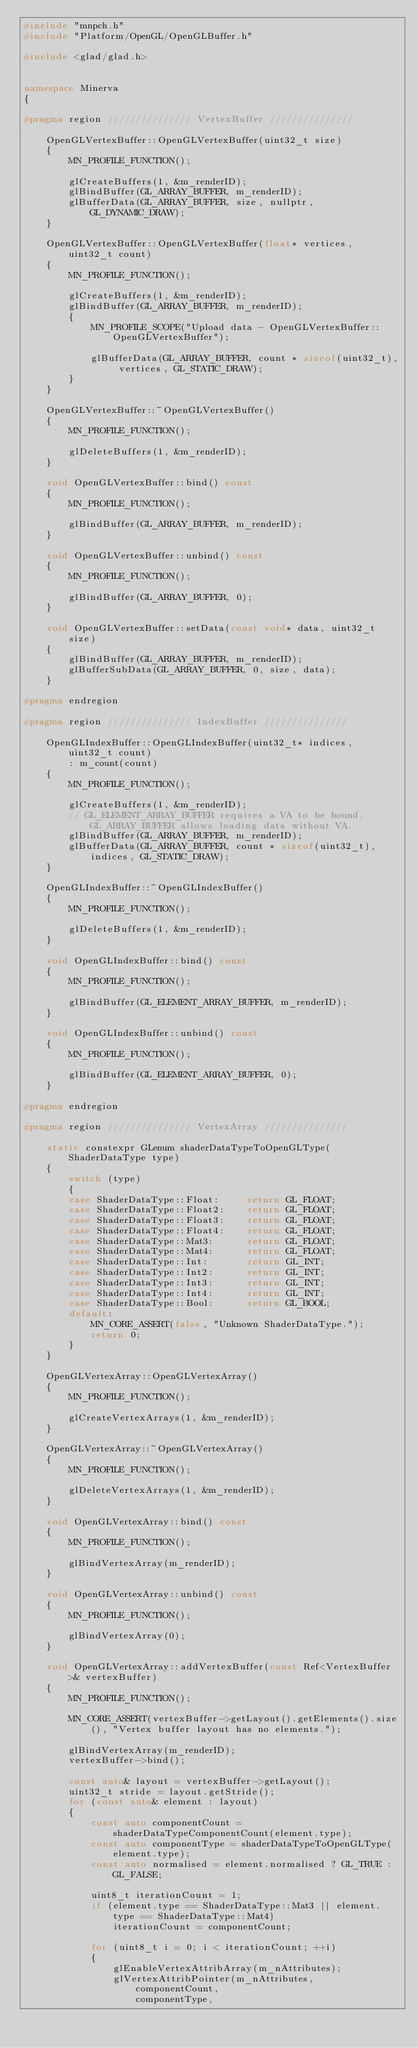Convert code to text. <code><loc_0><loc_0><loc_500><loc_500><_C++_>#include "mnpch.h"
#include "Platform/OpenGL/OpenGLBuffer.h"

#include <glad/glad.h>


namespace Minerva
{

#pragma region /////////////// VertexBuffer ///////////////

	OpenGLVertexBuffer::OpenGLVertexBuffer(uint32_t size)
	{
		MN_PROFILE_FUNCTION();

		glCreateBuffers(1, &m_renderID);
		glBindBuffer(GL_ARRAY_BUFFER, m_renderID);
		glBufferData(GL_ARRAY_BUFFER, size, nullptr, GL_DYNAMIC_DRAW);
	}

	OpenGLVertexBuffer::OpenGLVertexBuffer(float* vertices, uint32_t count)
	{
		MN_PROFILE_FUNCTION();

		glCreateBuffers(1, &m_renderID);
		glBindBuffer(GL_ARRAY_BUFFER, m_renderID);
		{
			MN_PROFILE_SCOPE("Upload data - OpenGLVertexBuffer::OpenGLVertexBuffer");

			glBufferData(GL_ARRAY_BUFFER, count * sizeof(uint32_t), vertices, GL_STATIC_DRAW);
		}
	}

	OpenGLVertexBuffer::~OpenGLVertexBuffer()
	{
		MN_PROFILE_FUNCTION();

		glDeleteBuffers(1, &m_renderID);
	}

	void OpenGLVertexBuffer::bind() const
	{
		MN_PROFILE_FUNCTION();

		glBindBuffer(GL_ARRAY_BUFFER, m_renderID);
	}

	void OpenGLVertexBuffer::unbind() const
	{
		MN_PROFILE_FUNCTION();

		glBindBuffer(GL_ARRAY_BUFFER, 0);
	}

	void OpenGLVertexBuffer::setData(const void* data, uint32_t size)
	{
		glBindBuffer(GL_ARRAY_BUFFER, m_renderID);
		glBufferSubData(GL_ARRAY_BUFFER, 0, size, data);
	}

#pragma endregion

#pragma region /////////////// IndexBuffer ///////////////

	OpenGLIndexBuffer::OpenGLIndexBuffer(uint32_t* indices, uint32_t count)
		: m_count(count)
	{
		MN_PROFILE_FUNCTION();

		glCreateBuffers(1, &m_renderID);
		// GL_ELEMENT_ARRAY_BUFFER requires a VA to be bound, GL_ARRAY_BUFFER allows loading data without VA.
		glBindBuffer(GL_ARRAY_BUFFER, m_renderID);
		glBufferData(GL_ARRAY_BUFFER, count * sizeof(uint32_t), indices, GL_STATIC_DRAW);
	}

	OpenGLIndexBuffer::~OpenGLIndexBuffer()
	{
		MN_PROFILE_FUNCTION();

		glDeleteBuffers(1, &m_renderID);
	}

	void OpenGLIndexBuffer::bind() const
	{
		MN_PROFILE_FUNCTION();

		glBindBuffer(GL_ELEMENT_ARRAY_BUFFER, m_renderID);
	}

	void OpenGLIndexBuffer::unbind() const
	{
		MN_PROFILE_FUNCTION();

		glBindBuffer(GL_ELEMENT_ARRAY_BUFFER, 0);
	}

#pragma endregion

#pragma region /////////////// VertexArray ///////////////

	static constexpr GLenum shaderDataTypeToOpenGLType(ShaderDataType type)
	{
		switch (type)
		{
		case ShaderDataType::Float:		return GL_FLOAT;
		case ShaderDataType::Float2:	return GL_FLOAT;
		case ShaderDataType::Float3:	return GL_FLOAT;
		case ShaderDataType::Float4:	return GL_FLOAT;
		case ShaderDataType::Mat3:		return GL_FLOAT;
		case ShaderDataType::Mat4:		return GL_FLOAT;
		case ShaderDataType::Int:		return GL_INT;
		case ShaderDataType::Int2:		return GL_INT;
		case ShaderDataType::Int3:		return GL_INT;
		case ShaderDataType::Int4:		return GL_INT;
		case ShaderDataType::Bool:		return GL_BOOL;
		default:
			MN_CORE_ASSERT(false, "Unknown ShaderDataType.");
			return 0;
		}
	}

	OpenGLVertexArray::OpenGLVertexArray()
	{
		MN_PROFILE_FUNCTION();

		glCreateVertexArrays(1, &m_renderID);
	}

	OpenGLVertexArray::~OpenGLVertexArray()
	{
		MN_PROFILE_FUNCTION();

		glDeleteVertexArrays(1, &m_renderID);
	}

	void OpenGLVertexArray::bind() const
	{
		MN_PROFILE_FUNCTION();

		glBindVertexArray(m_renderID);
	}

	void OpenGLVertexArray::unbind() const
	{
		MN_PROFILE_FUNCTION();

		glBindVertexArray(0);
	}

	void OpenGLVertexArray::addVertexBuffer(const Ref<VertexBuffer>& vertexBuffer)
	{
		MN_PROFILE_FUNCTION();

		MN_CORE_ASSERT(vertexBuffer->getLayout().getElements().size(), "Vertex buffer layout has no elements.");

		glBindVertexArray(m_renderID);
		vertexBuffer->bind();

		const auto& layout = vertexBuffer->getLayout();
		uint32_t stride = layout.getStride();
		for (const auto& element : layout)
		{
			const auto componentCount = shaderDataTypeComponentCount(element.type);
			const auto componentType = shaderDataTypeToOpenGLType(element.type);
			const auto normalised = element.normalised ? GL_TRUE : GL_FALSE;

			uint8_t iterationCount = 1;
			if (element.type == ShaderDataType::Mat3 || element.type == ShaderDataType::Mat4)
				iterationCount = componentCount;

			for (uint8_t i = 0; i < iterationCount; ++i)
			{
				glEnableVertexAttribArray(m_nAttributes);
				glVertexAttribPointer(m_nAttributes,
					componentCount,
					componentType,</code> 